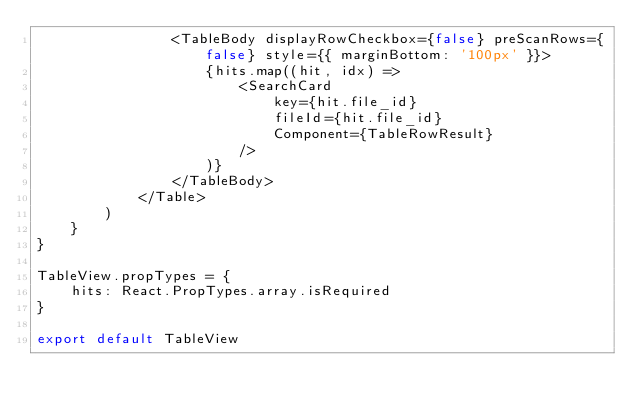Convert code to text. <code><loc_0><loc_0><loc_500><loc_500><_JavaScript_>                <TableBody displayRowCheckbox={false} preScanRows={false} style={{ marginBottom: '100px' }}>
                    {hits.map((hit, idx) =>
                        <SearchCard
                            key={hit.file_id}
                            fileId={hit.file_id}
                            Component={TableRowResult}
                        />
                    )}
                </TableBody>
            </Table>
        )
    }
}

TableView.propTypes = {
    hits: React.PropTypes.array.isRequired
}

export default TableView
</code> 